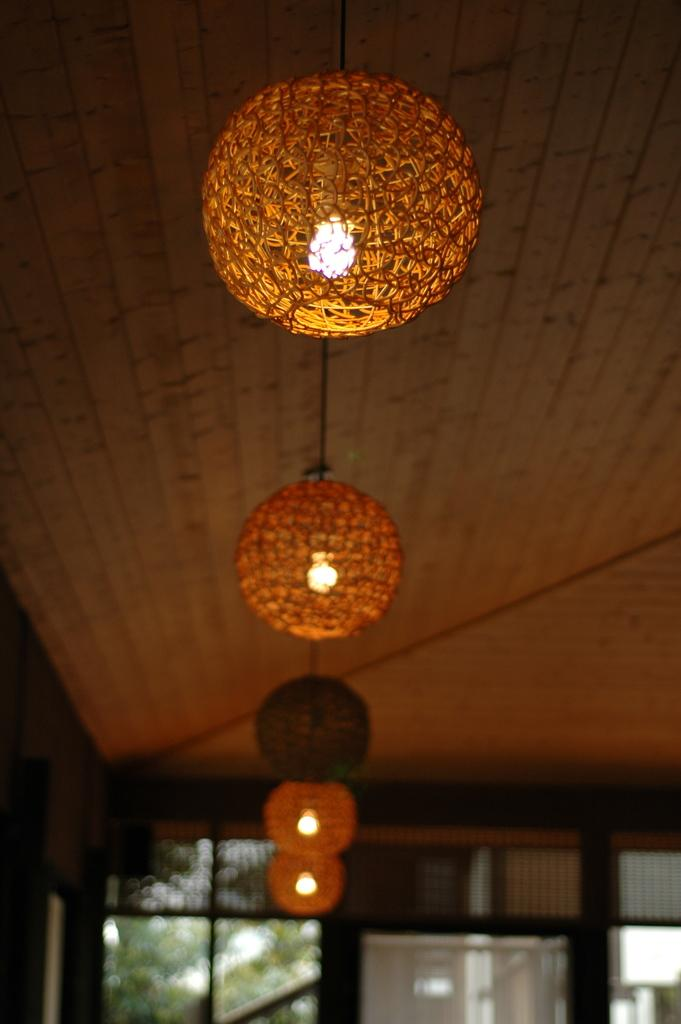What can be seen in the image that provides illumination? There are lights in the image. What structure is present in the image that covers the top? There is a roof in the image. How would you describe the appearance of the background in the image? The background of the image is blurry. What material is visible in the image that is transparent or translucent? There is glass visible in the image. What type of trouble is the yard experiencing in the image? There is no yard present in the image, and therefore no trouble can be observed. What nerve is being stimulated by the lights in the image? The image does not provide information about nerves or their stimulation; it only shows lights. 